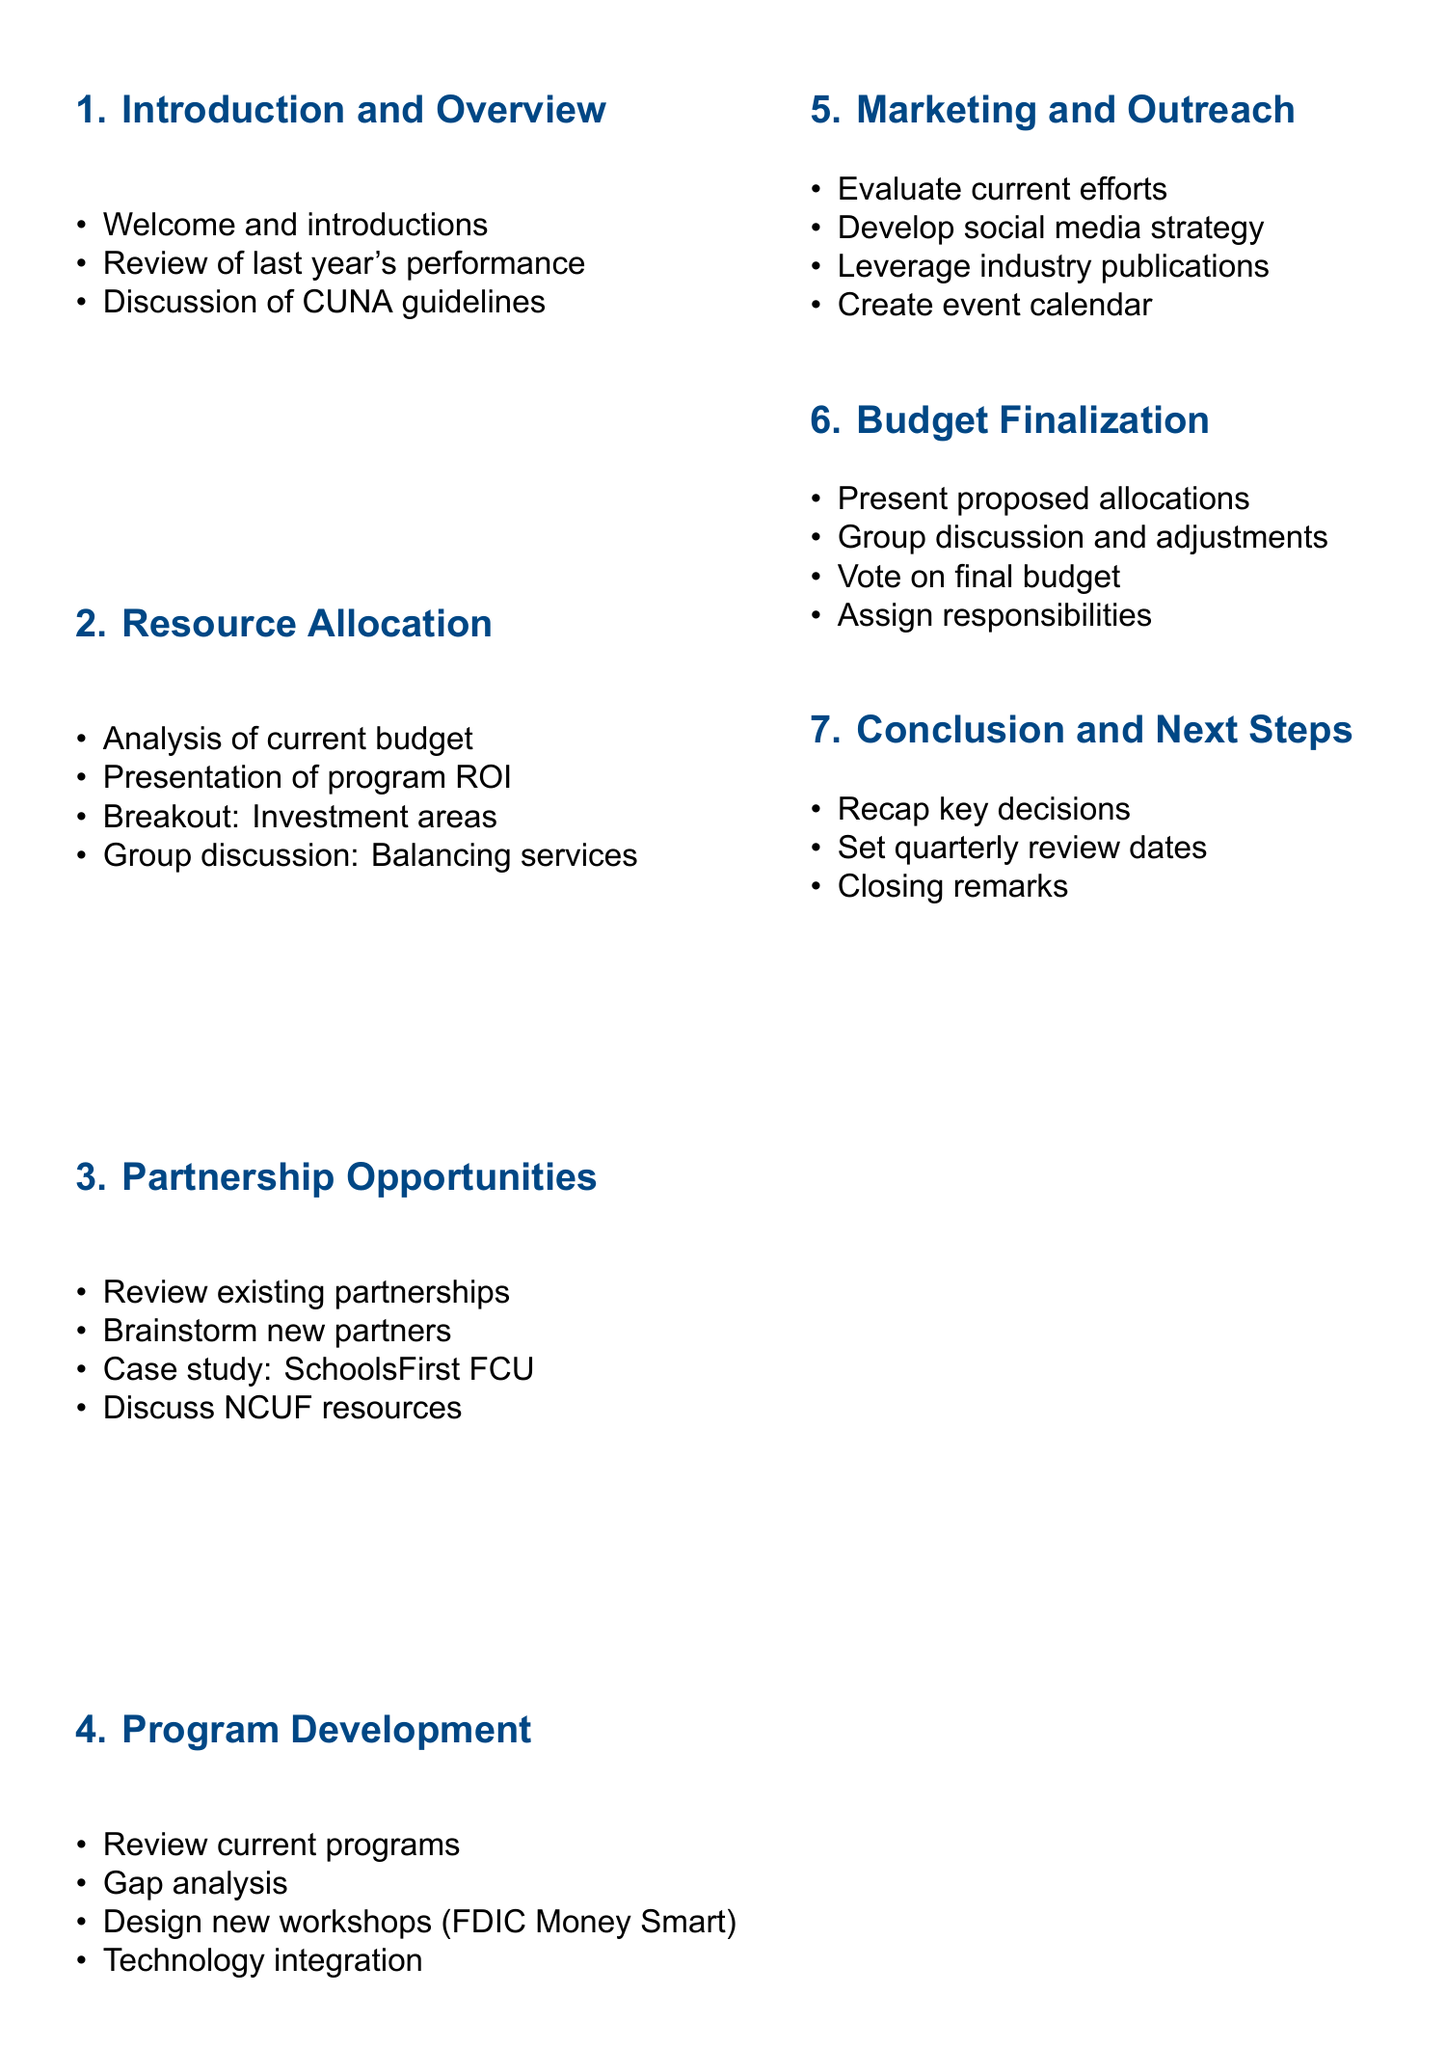What is the title of the workshop? The title of the workshop is provided at the beginning of the document, which is "Annual Budget Planning for Financial Literacy Programs."
Answer: Annual Budget Planning for Financial Literacy Programs Who is the target audience for the workshop? The target audience is specified in the document as the group that the workshop is aimed at, which includes credit union employees and community partners.
Answer: Credit union employees and community partners How long is the workshop scheduled to last? The duration of the workshop is stated clearly in the document as a full-day workshop.
Answer: Full-day workshop What resource is needed for breakout sessions? Among the resources listed, the document mentions that laptops are specifically needed for breakout sessions.
Answer: Laptops for breakout sessions What topic is covered in the "Program Development and Enhancement" section? This section covers various aspects of current programs and their improvement, specifically looking at a gap analysis to identify underserved demographics or topics.
Answer: Gap analysis What is a proposed action following the workshop? The document outlines several post-workshop actions, one of which is to distribute meeting minutes and the finalized budget to all participants.
Answer: Distribute meeting minutes and finalized budget What will be discussed regarding partnerships? The document specifies that there will be a brainstorming session for potential new partners to expand the reach of the financial literacy programs.
Answer: Brainstorming session: Potential new partners for expanded reach How many sections are there in the workshop agenda? The number of sections is counted from the document, which lists seven distinct sections in total for the agenda.
Answer: Seven What is the main focus of the "Marketing and Outreach Strategies" section? This section focuses on evaluating current marketing efforts and developing a social media strategy for program promotion.
Answer: Evaluation of current marketing efforts for financial literacy programs What is the final action item in the workshop? The document concludes with setting quarterly review dates for program progress, indicating an ongoing commitment to tracking and assessing the program's effectiveness.
Answer: Setting quarterly review dates for program progress 